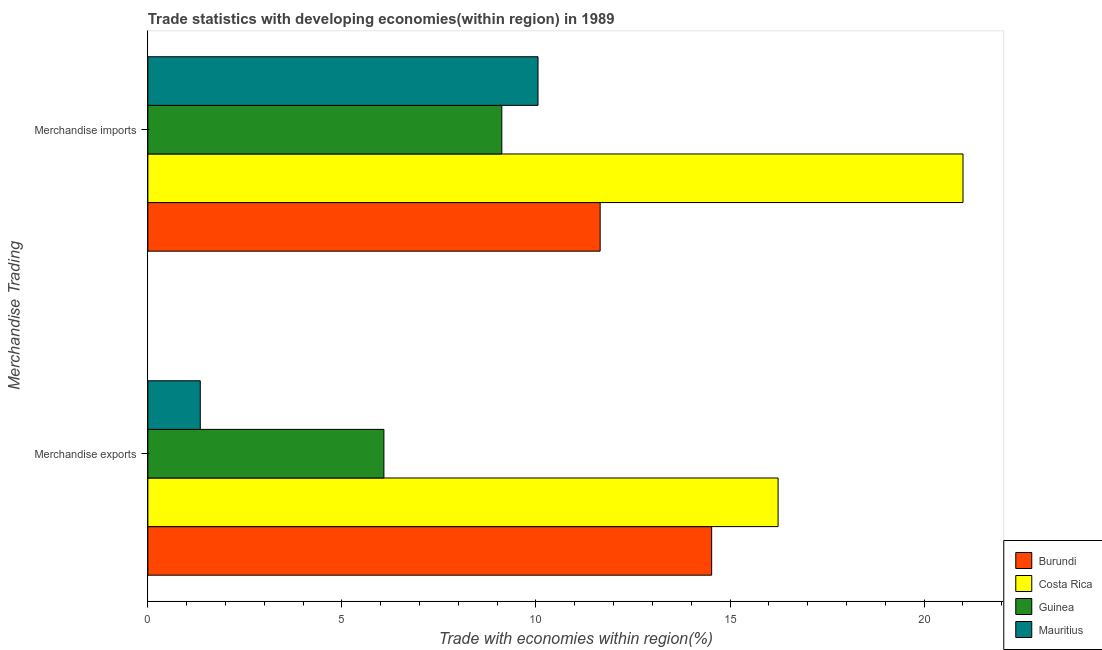How many groups of bars are there?
Give a very brief answer. 2. Are the number of bars per tick equal to the number of legend labels?
Make the answer very short. Yes. Are the number of bars on each tick of the Y-axis equal?
Make the answer very short. Yes. How many bars are there on the 1st tick from the bottom?
Make the answer very short. 4. What is the merchandise imports in Guinea?
Ensure brevity in your answer.  9.12. Across all countries, what is the maximum merchandise imports?
Your answer should be very brief. 21. Across all countries, what is the minimum merchandise imports?
Provide a succinct answer. 9.12. In which country was the merchandise exports maximum?
Your answer should be very brief. Costa Rica. In which country was the merchandise imports minimum?
Give a very brief answer. Guinea. What is the total merchandise imports in the graph?
Make the answer very short. 51.83. What is the difference between the merchandise imports in Guinea and that in Burundi?
Provide a short and direct response. -2.53. What is the difference between the merchandise imports in Burundi and the merchandise exports in Guinea?
Give a very brief answer. 5.57. What is the average merchandise imports per country?
Your answer should be compact. 12.96. What is the difference between the merchandise exports and merchandise imports in Guinea?
Your answer should be very brief. -3.04. What is the ratio of the merchandise imports in Mauritius to that in Burundi?
Provide a succinct answer. 0.86. What does the 4th bar from the top in Merchandise imports represents?
Ensure brevity in your answer.  Burundi. What is the difference between two consecutive major ticks on the X-axis?
Keep it short and to the point. 5. Are the values on the major ticks of X-axis written in scientific E-notation?
Keep it short and to the point. No. Where does the legend appear in the graph?
Provide a succinct answer. Bottom right. How are the legend labels stacked?
Your response must be concise. Vertical. What is the title of the graph?
Your answer should be compact. Trade statistics with developing economies(within region) in 1989. Does "Japan" appear as one of the legend labels in the graph?
Provide a succinct answer. No. What is the label or title of the X-axis?
Offer a terse response. Trade with economies within region(%). What is the label or title of the Y-axis?
Your answer should be very brief. Merchandise Trading. What is the Trade with economies within region(%) of Burundi in Merchandise exports?
Your answer should be very brief. 14.53. What is the Trade with economies within region(%) of Costa Rica in Merchandise exports?
Provide a succinct answer. 16.24. What is the Trade with economies within region(%) in Guinea in Merchandise exports?
Provide a short and direct response. 6.08. What is the Trade with economies within region(%) of Mauritius in Merchandise exports?
Offer a very short reply. 1.35. What is the Trade with economies within region(%) in Burundi in Merchandise imports?
Give a very brief answer. 11.65. What is the Trade with economies within region(%) of Costa Rica in Merchandise imports?
Offer a very short reply. 21. What is the Trade with economies within region(%) of Guinea in Merchandise imports?
Offer a terse response. 9.12. What is the Trade with economies within region(%) of Mauritius in Merchandise imports?
Your response must be concise. 10.05. Across all Merchandise Trading, what is the maximum Trade with economies within region(%) of Burundi?
Your answer should be very brief. 14.53. Across all Merchandise Trading, what is the maximum Trade with economies within region(%) in Costa Rica?
Offer a very short reply. 21. Across all Merchandise Trading, what is the maximum Trade with economies within region(%) of Guinea?
Your answer should be very brief. 9.12. Across all Merchandise Trading, what is the maximum Trade with economies within region(%) of Mauritius?
Keep it short and to the point. 10.05. Across all Merchandise Trading, what is the minimum Trade with economies within region(%) of Burundi?
Make the answer very short. 11.65. Across all Merchandise Trading, what is the minimum Trade with economies within region(%) in Costa Rica?
Offer a terse response. 16.24. Across all Merchandise Trading, what is the minimum Trade with economies within region(%) in Guinea?
Your answer should be compact. 6.08. Across all Merchandise Trading, what is the minimum Trade with economies within region(%) in Mauritius?
Your answer should be very brief. 1.35. What is the total Trade with economies within region(%) of Burundi in the graph?
Offer a very short reply. 26.18. What is the total Trade with economies within region(%) of Costa Rica in the graph?
Ensure brevity in your answer.  37.24. What is the total Trade with economies within region(%) in Guinea in the graph?
Provide a short and direct response. 15.2. What is the total Trade with economies within region(%) of Mauritius in the graph?
Your answer should be compact. 11.4. What is the difference between the Trade with economies within region(%) in Burundi in Merchandise exports and that in Merchandise imports?
Keep it short and to the point. 2.87. What is the difference between the Trade with economies within region(%) in Costa Rica in Merchandise exports and that in Merchandise imports?
Offer a terse response. -4.76. What is the difference between the Trade with economies within region(%) of Guinea in Merchandise exports and that in Merchandise imports?
Your answer should be compact. -3.04. What is the difference between the Trade with economies within region(%) of Mauritius in Merchandise exports and that in Merchandise imports?
Your answer should be compact. -8.7. What is the difference between the Trade with economies within region(%) of Burundi in Merchandise exports and the Trade with economies within region(%) of Costa Rica in Merchandise imports?
Provide a short and direct response. -6.48. What is the difference between the Trade with economies within region(%) in Burundi in Merchandise exports and the Trade with economies within region(%) in Guinea in Merchandise imports?
Provide a short and direct response. 5.41. What is the difference between the Trade with economies within region(%) of Burundi in Merchandise exports and the Trade with economies within region(%) of Mauritius in Merchandise imports?
Your response must be concise. 4.47. What is the difference between the Trade with economies within region(%) in Costa Rica in Merchandise exports and the Trade with economies within region(%) in Guinea in Merchandise imports?
Your answer should be very brief. 7.12. What is the difference between the Trade with economies within region(%) of Costa Rica in Merchandise exports and the Trade with economies within region(%) of Mauritius in Merchandise imports?
Your answer should be compact. 6.19. What is the difference between the Trade with economies within region(%) in Guinea in Merchandise exports and the Trade with economies within region(%) in Mauritius in Merchandise imports?
Ensure brevity in your answer.  -3.97. What is the average Trade with economies within region(%) in Burundi per Merchandise Trading?
Make the answer very short. 13.09. What is the average Trade with economies within region(%) in Costa Rica per Merchandise Trading?
Ensure brevity in your answer.  18.62. What is the average Trade with economies within region(%) of Guinea per Merchandise Trading?
Your response must be concise. 7.6. What is the average Trade with economies within region(%) in Mauritius per Merchandise Trading?
Provide a short and direct response. 5.7. What is the difference between the Trade with economies within region(%) of Burundi and Trade with economies within region(%) of Costa Rica in Merchandise exports?
Provide a succinct answer. -1.71. What is the difference between the Trade with economies within region(%) in Burundi and Trade with economies within region(%) in Guinea in Merchandise exports?
Your answer should be very brief. 8.44. What is the difference between the Trade with economies within region(%) in Burundi and Trade with economies within region(%) in Mauritius in Merchandise exports?
Your answer should be compact. 13.18. What is the difference between the Trade with economies within region(%) in Costa Rica and Trade with economies within region(%) in Guinea in Merchandise exports?
Your response must be concise. 10.16. What is the difference between the Trade with economies within region(%) of Costa Rica and Trade with economies within region(%) of Mauritius in Merchandise exports?
Your response must be concise. 14.89. What is the difference between the Trade with economies within region(%) in Guinea and Trade with economies within region(%) in Mauritius in Merchandise exports?
Keep it short and to the point. 4.73. What is the difference between the Trade with economies within region(%) of Burundi and Trade with economies within region(%) of Costa Rica in Merchandise imports?
Ensure brevity in your answer.  -9.35. What is the difference between the Trade with economies within region(%) of Burundi and Trade with economies within region(%) of Guinea in Merchandise imports?
Give a very brief answer. 2.53. What is the difference between the Trade with economies within region(%) in Burundi and Trade with economies within region(%) in Mauritius in Merchandise imports?
Provide a succinct answer. 1.6. What is the difference between the Trade with economies within region(%) of Costa Rica and Trade with economies within region(%) of Guinea in Merchandise imports?
Your answer should be very brief. 11.88. What is the difference between the Trade with economies within region(%) of Costa Rica and Trade with economies within region(%) of Mauritius in Merchandise imports?
Your response must be concise. 10.95. What is the difference between the Trade with economies within region(%) in Guinea and Trade with economies within region(%) in Mauritius in Merchandise imports?
Offer a very short reply. -0.93. What is the ratio of the Trade with economies within region(%) of Burundi in Merchandise exports to that in Merchandise imports?
Ensure brevity in your answer.  1.25. What is the ratio of the Trade with economies within region(%) of Costa Rica in Merchandise exports to that in Merchandise imports?
Provide a succinct answer. 0.77. What is the ratio of the Trade with economies within region(%) of Guinea in Merchandise exports to that in Merchandise imports?
Offer a very short reply. 0.67. What is the ratio of the Trade with economies within region(%) in Mauritius in Merchandise exports to that in Merchandise imports?
Your response must be concise. 0.13. What is the difference between the highest and the second highest Trade with economies within region(%) of Burundi?
Make the answer very short. 2.87. What is the difference between the highest and the second highest Trade with economies within region(%) in Costa Rica?
Your answer should be very brief. 4.76. What is the difference between the highest and the second highest Trade with economies within region(%) of Guinea?
Your response must be concise. 3.04. What is the difference between the highest and the second highest Trade with economies within region(%) of Mauritius?
Your answer should be very brief. 8.7. What is the difference between the highest and the lowest Trade with economies within region(%) in Burundi?
Provide a succinct answer. 2.87. What is the difference between the highest and the lowest Trade with economies within region(%) in Costa Rica?
Offer a terse response. 4.76. What is the difference between the highest and the lowest Trade with economies within region(%) in Guinea?
Your response must be concise. 3.04. What is the difference between the highest and the lowest Trade with economies within region(%) of Mauritius?
Keep it short and to the point. 8.7. 